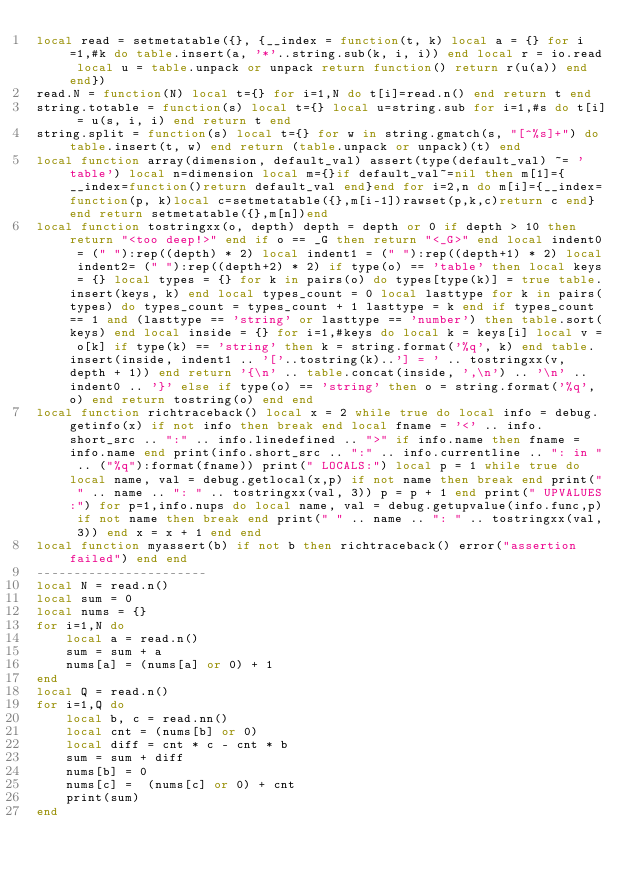Convert code to text. <code><loc_0><loc_0><loc_500><loc_500><_Lua_>local read = setmetatable({}, {__index = function(t, k) local a = {} for i=1,#k do table.insert(a, '*'..string.sub(k, i, i)) end local r = io.read local u = table.unpack or unpack return function() return r(u(a)) end end})
read.N = function(N) local t={} for i=1,N do t[i]=read.n() end return t end
string.totable = function(s) local t={} local u=string.sub for i=1,#s do t[i] = u(s, i, i) end return t end
string.split = function(s) local t={} for w in string.gmatch(s, "[^%s]+") do table.insert(t, w) end return (table.unpack or unpack)(t) end
local function array(dimension, default_val) assert(type(default_val) ~= 'table') local n=dimension local m={}if default_val~=nil then m[1]={__index=function()return default_val end}end for i=2,n do m[i]={__index=function(p, k)local c=setmetatable({},m[i-1])rawset(p,k,c)return c end}end return setmetatable({},m[n])end
local function tostringxx(o, depth) depth = depth or 0 if depth > 10 then return "<too deep!>" end if o == _G then return "<_G>" end local indent0 = (" "):rep((depth) * 2) local indent1 = (" "):rep((depth+1) * 2) local indent2= (" "):rep((depth+2) * 2) if type(o) == 'table' then local keys = {} local types = {} for k in pairs(o) do types[type(k)] = true table.insert(keys, k) end local types_count = 0 local lasttype for k in pairs(types) do types_count = types_count + 1 lasttype = k end if types_count == 1 and (lasttype == 'string' or lasttype == 'number') then table.sort(keys) end local inside = {} for i=1,#keys do local k = keys[i] local v = o[k] if type(k) == 'string' then k = string.format('%q', k) end table.insert(inside, indent1 .. '['..tostring(k)..'] = ' .. tostringxx(v, depth + 1)) end return '{\n' .. table.concat(inside, ',\n') .. '\n' .. indent0 .. '}' else if type(o) == 'string' then o = string.format('%q', o) end return tostring(o) end end
local function richtraceback() local x = 2 while true do local info = debug.getinfo(x) if not info then break end local fname = '<' .. info.short_src .. ":" .. info.linedefined .. ">" if info.name then fname = info.name end print(info.short_src .. ":" .. info.currentline .. ": in " .. ("%q"):format(fname)) print(" LOCALS:") local p = 1 while true do local name, val = debug.getlocal(x,p) if not name then break end print(" " .. name .. ": " .. tostringxx(val, 3)) p = p + 1 end print(" UPVALUES:") for p=1,info.nups do local name, val = debug.getupvalue(info.func,p) if not name then break end print(" " .. name .. ": " .. tostringxx(val, 3)) end x = x + 1 end end
local function myassert(b) if not b then richtraceback() error("assertion failed") end end 
-----------------------
local N = read.n()
local sum = 0
local nums = {}
for i=1,N do
    local a = read.n()
    sum = sum + a
    nums[a] = (nums[a] or 0) + 1
end
local Q = read.n()
for i=1,Q do
    local b, c = read.nn()
    local cnt = (nums[b] or 0)
    local diff = cnt * c - cnt * b
    sum = sum + diff
    nums[b] = 0
    nums[c] =  (nums[c] or 0) + cnt
    print(sum)
end
</code> 